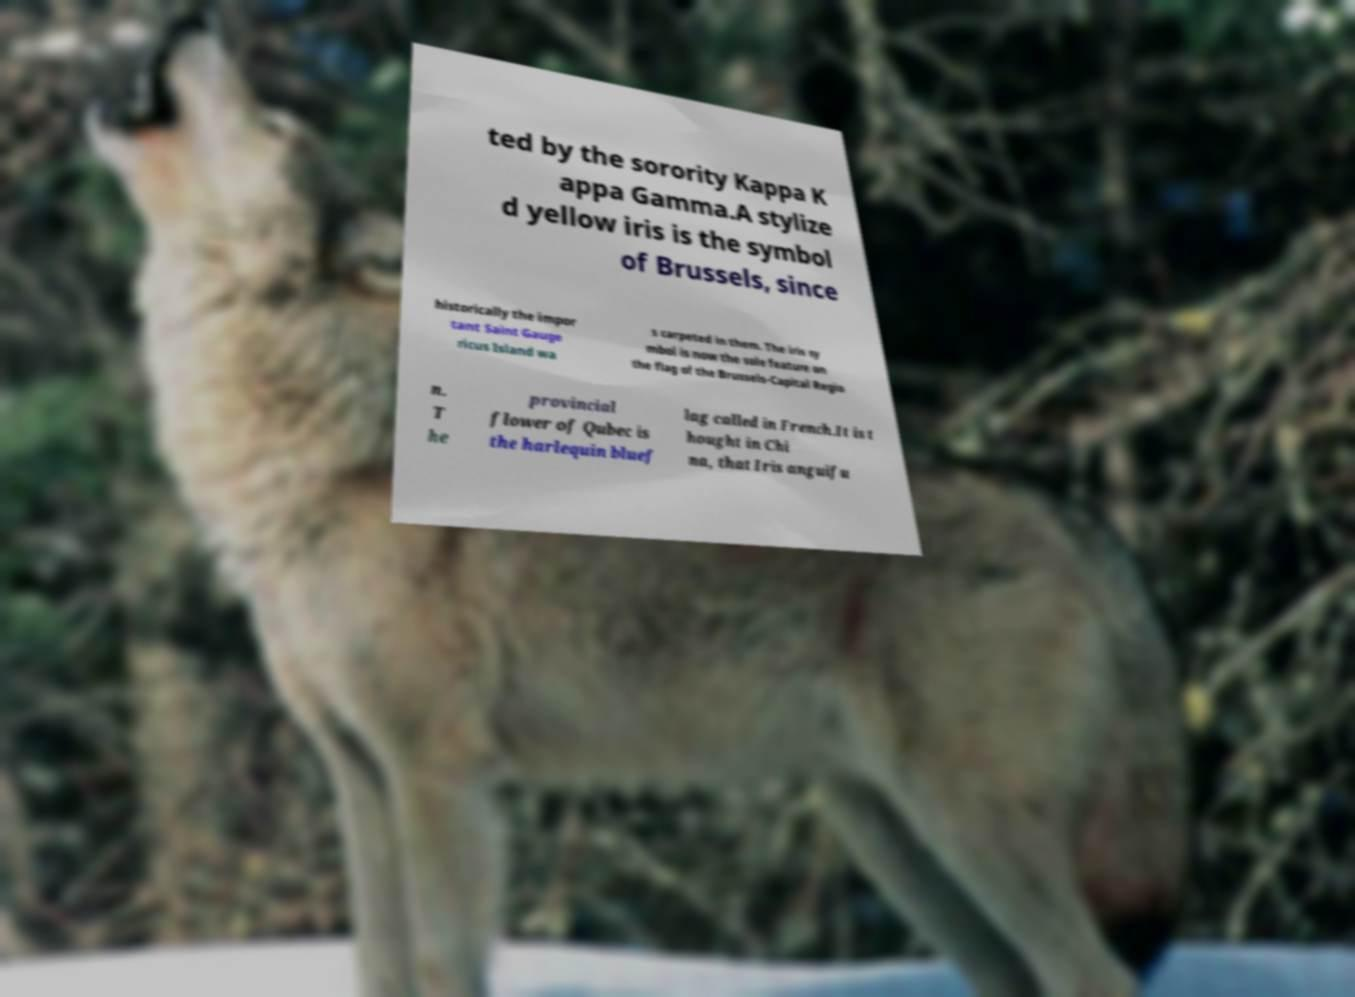Can you read and provide the text displayed in the image?This photo seems to have some interesting text. Can you extract and type it out for me? ted by the sorority Kappa K appa Gamma.A stylize d yellow iris is the symbol of Brussels, since historically the impor tant Saint Gauge ricus Island wa s carpeted in them. The iris sy mbol is now the sole feature on the flag of the Brussels-Capital Regio n. T he provincial flower of Qubec is the harlequin bluef lag called in French.It is t hought in Chi na, that Iris anguifu 